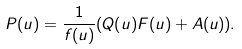Convert formula to latex. <formula><loc_0><loc_0><loc_500><loc_500>P ( u ) = \frac { 1 } { f ( u ) } ( Q ( u ) F ( u ) + A ( u ) ) .</formula> 